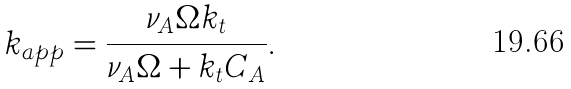<formula> <loc_0><loc_0><loc_500><loc_500>k _ { a p p } = \frac { \nu _ { A } \Omega k _ { t } } { \nu _ { A } \Omega + k _ { t } C _ { A } } .</formula> 